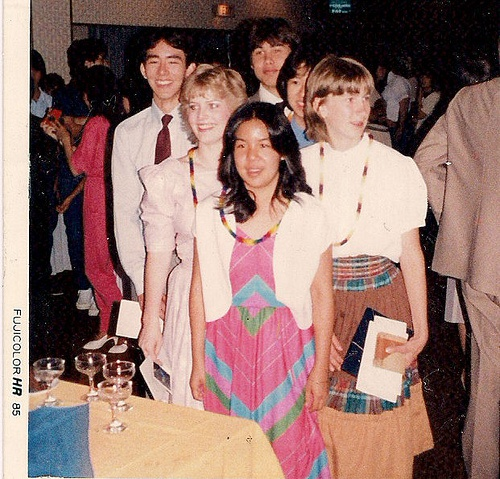Describe the objects in this image and their specific colors. I can see people in white, lightgray, lightpink, salmon, and black tones, people in white, lightgray, salmon, brown, and tan tones, people in white, gray, salmon, and tan tones, people in white, lightgray, lightpink, tan, and brown tones, and people in white, lightgray, black, and lightpink tones in this image. 